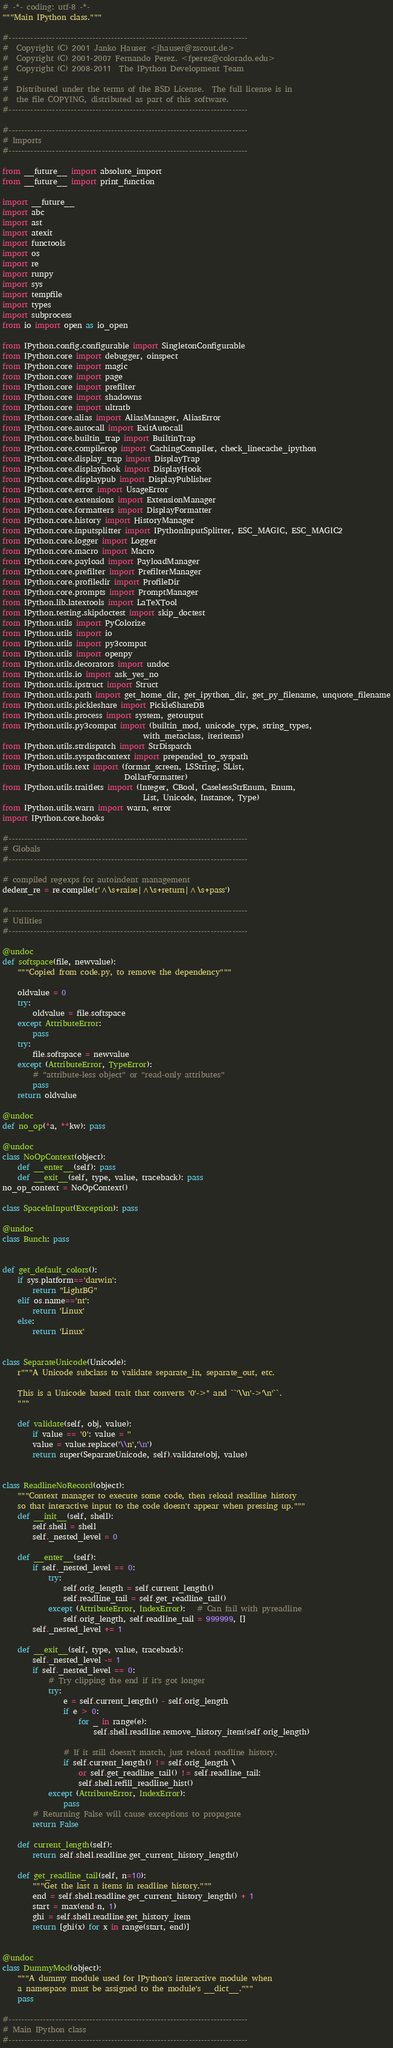Convert code to text. <code><loc_0><loc_0><loc_500><loc_500><_Python_># -*- coding: utf-8 -*-
"""Main IPython class."""

#-----------------------------------------------------------------------------
#  Copyright (C) 2001 Janko Hauser <jhauser@zscout.de>
#  Copyright (C) 2001-2007 Fernando Perez. <fperez@colorado.edu>
#  Copyright (C) 2008-2011  The IPython Development Team
#
#  Distributed under the terms of the BSD License.  The full license is in
#  the file COPYING, distributed as part of this software.
#-----------------------------------------------------------------------------

#-----------------------------------------------------------------------------
# Imports
#-----------------------------------------------------------------------------

from __future__ import absolute_import
from __future__ import print_function

import __future__
import abc
import ast
import atexit
import functools
import os
import re
import runpy
import sys
import tempfile
import types
import subprocess
from io import open as io_open

from IPython.config.configurable import SingletonConfigurable
from IPython.core import debugger, oinspect
from IPython.core import magic
from IPython.core import page
from IPython.core import prefilter
from IPython.core import shadowns
from IPython.core import ultratb
from IPython.core.alias import AliasManager, AliasError
from IPython.core.autocall import ExitAutocall
from IPython.core.builtin_trap import BuiltinTrap
from IPython.core.compilerop import CachingCompiler, check_linecache_ipython
from IPython.core.display_trap import DisplayTrap
from IPython.core.displayhook import DisplayHook
from IPython.core.displaypub import DisplayPublisher
from IPython.core.error import UsageError
from IPython.core.extensions import ExtensionManager
from IPython.core.formatters import DisplayFormatter
from IPython.core.history import HistoryManager
from IPython.core.inputsplitter import IPythonInputSplitter, ESC_MAGIC, ESC_MAGIC2
from IPython.core.logger import Logger
from IPython.core.macro import Macro
from IPython.core.payload import PayloadManager
from IPython.core.prefilter import PrefilterManager
from IPython.core.profiledir import ProfileDir
from IPython.core.prompts import PromptManager
from IPython.lib.latextools import LaTeXTool
from IPython.testing.skipdoctest import skip_doctest
from IPython.utils import PyColorize
from IPython.utils import io
from IPython.utils import py3compat
from IPython.utils import openpy
from IPython.utils.decorators import undoc
from IPython.utils.io import ask_yes_no
from IPython.utils.ipstruct import Struct
from IPython.utils.path import get_home_dir, get_ipython_dir, get_py_filename, unquote_filename
from IPython.utils.pickleshare import PickleShareDB
from IPython.utils.process import system, getoutput
from IPython.utils.py3compat import (builtin_mod, unicode_type, string_types,
                                     with_metaclass, iteritems)
from IPython.utils.strdispatch import StrDispatch
from IPython.utils.syspathcontext import prepended_to_syspath
from IPython.utils.text import (format_screen, LSString, SList,
                                DollarFormatter)
from IPython.utils.traitlets import (Integer, CBool, CaselessStrEnum, Enum,
                                     List, Unicode, Instance, Type)
from IPython.utils.warn import warn, error
import IPython.core.hooks

#-----------------------------------------------------------------------------
# Globals
#-----------------------------------------------------------------------------

# compiled regexps for autoindent management
dedent_re = re.compile(r'^\s+raise|^\s+return|^\s+pass')

#-----------------------------------------------------------------------------
# Utilities
#-----------------------------------------------------------------------------

@undoc
def softspace(file, newvalue):
    """Copied from code.py, to remove the dependency"""

    oldvalue = 0
    try:
        oldvalue = file.softspace
    except AttributeError:
        pass
    try:
        file.softspace = newvalue
    except (AttributeError, TypeError):
        # "attribute-less object" or "read-only attributes"
        pass
    return oldvalue

@undoc
def no_op(*a, **kw): pass

@undoc
class NoOpContext(object):
    def __enter__(self): pass
    def __exit__(self, type, value, traceback): pass
no_op_context = NoOpContext()

class SpaceInInput(Exception): pass

@undoc
class Bunch: pass


def get_default_colors():
    if sys.platform=='darwin':
        return "LightBG"
    elif os.name=='nt':
        return 'Linux'
    else:
        return 'Linux'


class SeparateUnicode(Unicode):
    r"""A Unicode subclass to validate separate_in, separate_out, etc.

    This is a Unicode based trait that converts '0'->'' and ``'\\n'->'\n'``.
    """

    def validate(self, obj, value):
        if value == '0': value = ''
        value = value.replace('\\n','\n')
        return super(SeparateUnicode, self).validate(obj, value)


class ReadlineNoRecord(object):
    """Context manager to execute some code, then reload readline history
    so that interactive input to the code doesn't appear when pressing up."""
    def __init__(self, shell):
        self.shell = shell
        self._nested_level = 0

    def __enter__(self):
        if self._nested_level == 0:
            try:
                self.orig_length = self.current_length()
                self.readline_tail = self.get_readline_tail()
            except (AttributeError, IndexError):   # Can fail with pyreadline
                self.orig_length, self.readline_tail = 999999, []
        self._nested_level += 1

    def __exit__(self, type, value, traceback):
        self._nested_level -= 1
        if self._nested_level == 0:
            # Try clipping the end if it's got longer
            try:
                e = self.current_length() - self.orig_length
                if e > 0:
                    for _ in range(e):
                        self.shell.readline.remove_history_item(self.orig_length)

                # If it still doesn't match, just reload readline history.
                if self.current_length() != self.orig_length \
                    or self.get_readline_tail() != self.readline_tail:
                    self.shell.refill_readline_hist()
            except (AttributeError, IndexError):
                pass
        # Returning False will cause exceptions to propagate
        return False

    def current_length(self):
        return self.shell.readline.get_current_history_length()

    def get_readline_tail(self, n=10):
        """Get the last n items in readline history."""
        end = self.shell.readline.get_current_history_length() + 1
        start = max(end-n, 1)
        ghi = self.shell.readline.get_history_item
        return [ghi(x) for x in range(start, end)]


@undoc
class DummyMod(object):
    """A dummy module used for IPython's interactive module when
    a namespace must be assigned to the module's __dict__."""
    pass

#-----------------------------------------------------------------------------
# Main IPython class
#-----------------------------------------------------------------------------
</code> 